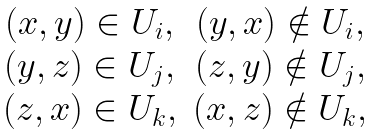<formula> <loc_0><loc_0><loc_500><loc_500>\begin{matrix} ( x , y ) \in U _ { i } , & ( y , x ) \notin U _ { i } , \\ ( y , z ) \in U _ { j } , & ( z , y ) \notin U _ { j } , \\ ( z , x ) \in U _ { k } , & ( x , z ) \notin U _ { k } , \end{matrix}</formula> 